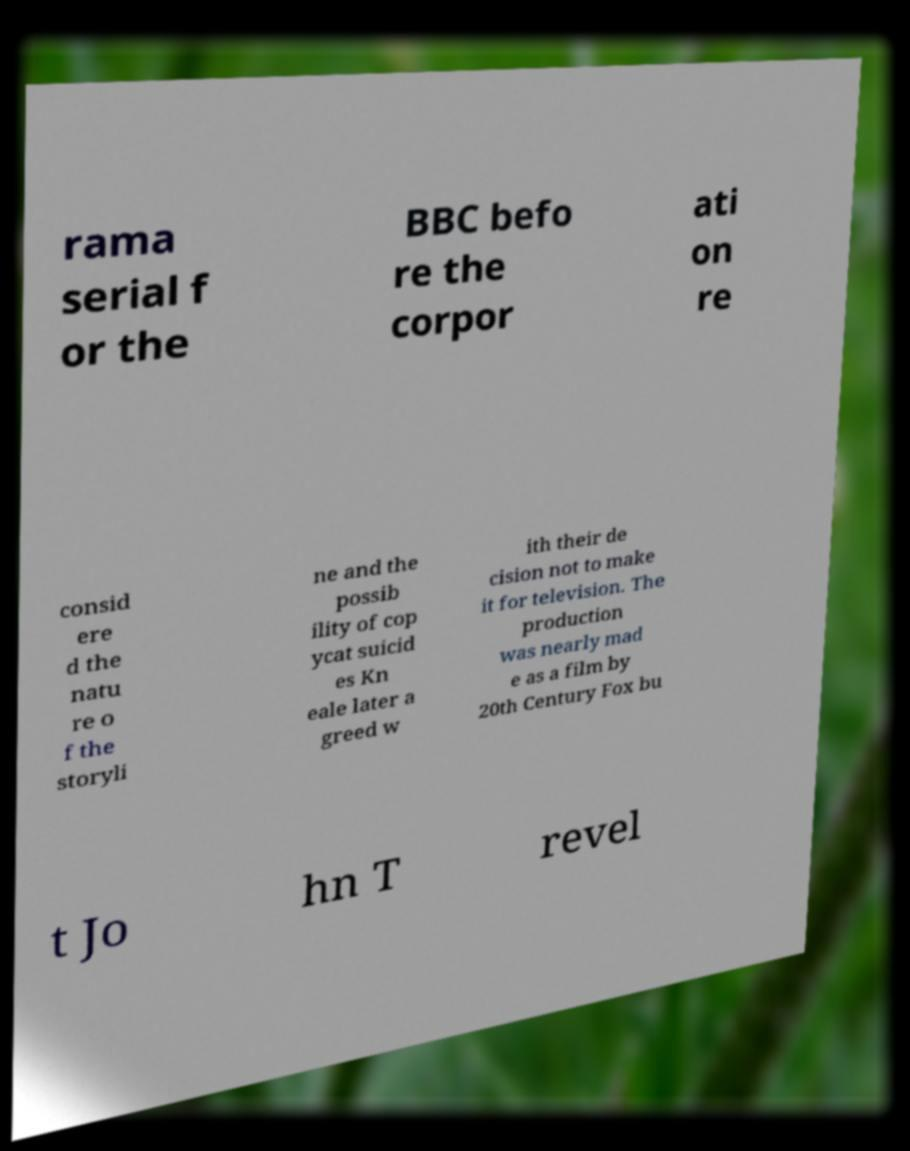There's text embedded in this image that I need extracted. Can you transcribe it verbatim? rama serial f or the BBC befo re the corpor ati on re consid ere d the natu re o f the storyli ne and the possib ility of cop ycat suicid es Kn eale later a greed w ith their de cision not to make it for television. The production was nearly mad e as a film by 20th Century Fox bu t Jo hn T revel 